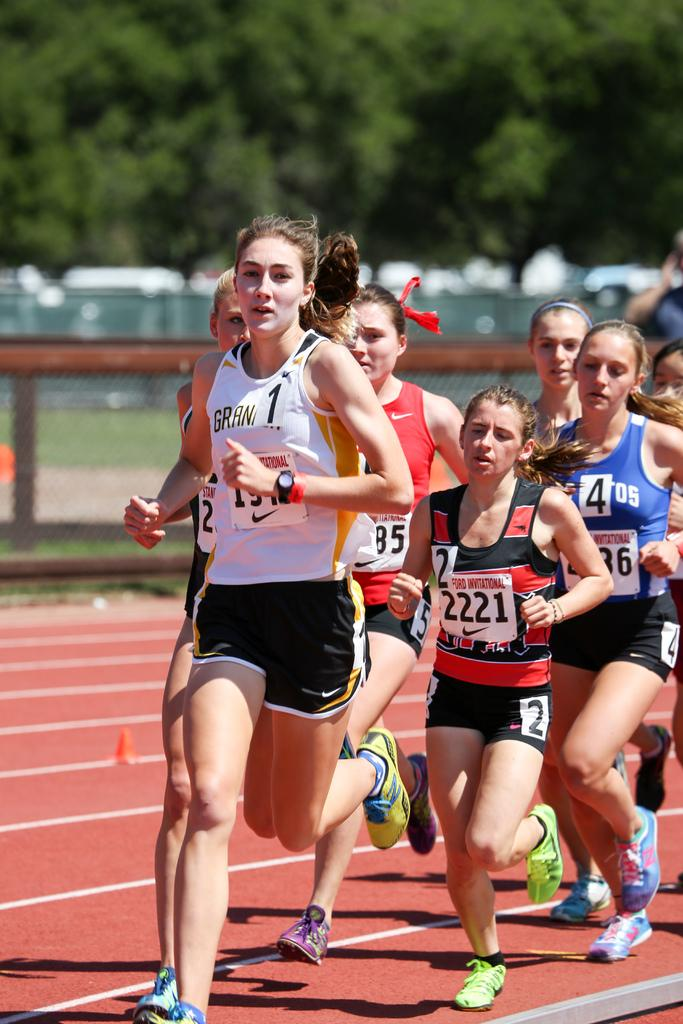<image>
Present a compact description of the photo's key features. Several young women are running on a track, with number tags on the front of their shirts that say Ford International. 